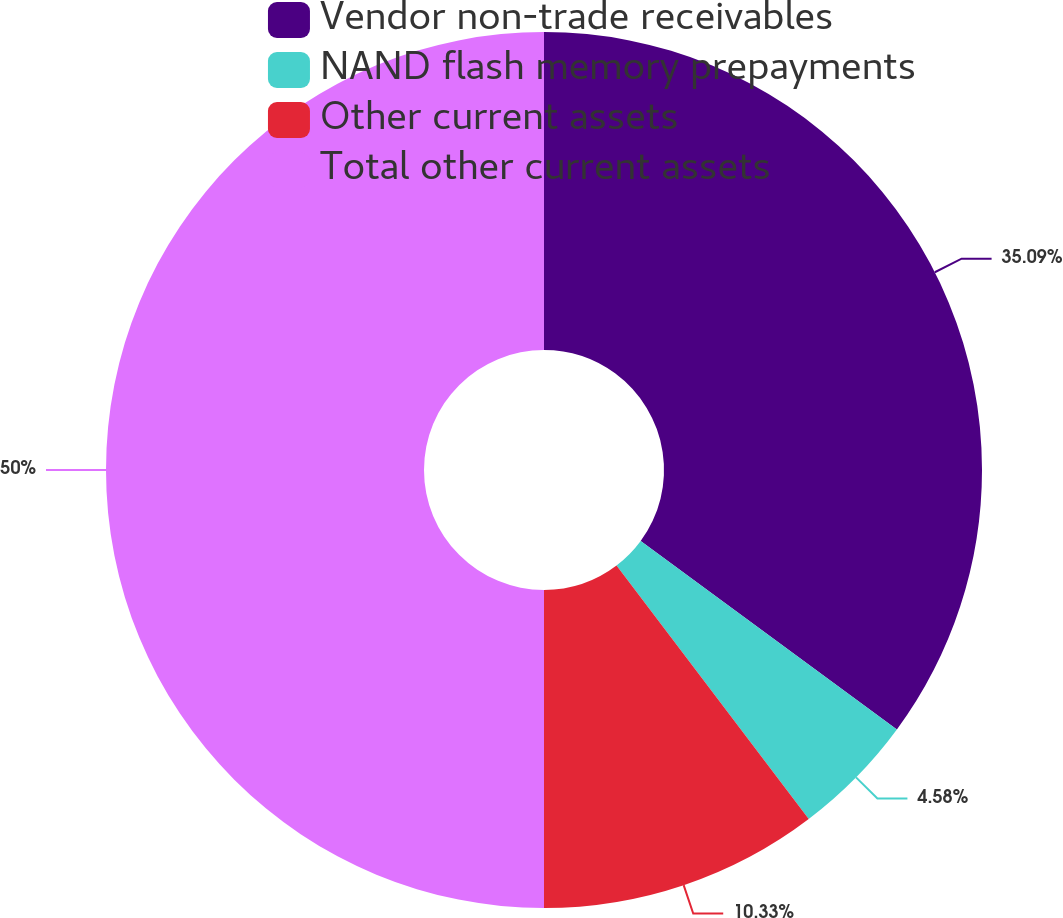Convert chart. <chart><loc_0><loc_0><loc_500><loc_500><pie_chart><fcel>Vendor non-trade receivables<fcel>NAND flash memory prepayments<fcel>Other current assets<fcel>Total other current assets<nl><fcel>35.09%<fcel>4.58%<fcel>10.33%<fcel>50.0%<nl></chart> 